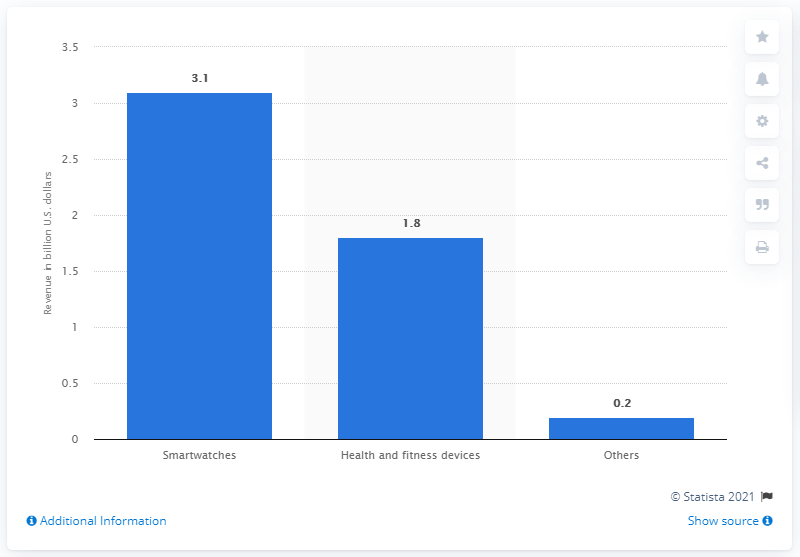Give some essential details in this illustration. According to predicted sales figures for smartwatches in the United States in 2015, the revenue is expected to reach a total of 3.1 billion dollars. 